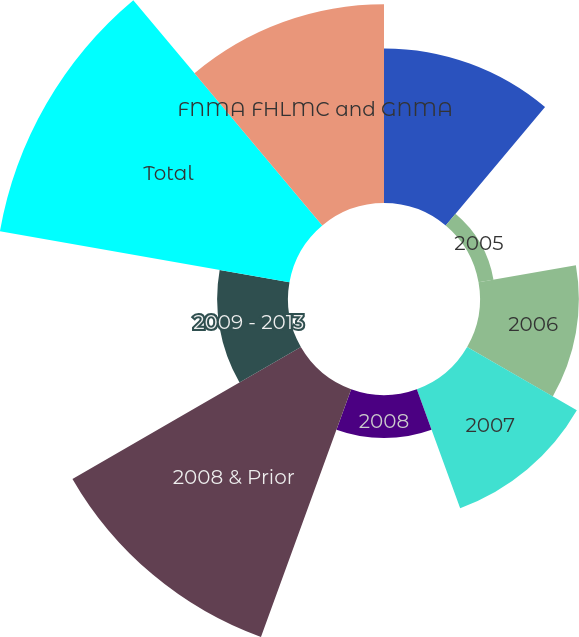Convert chart. <chart><loc_0><loc_0><loc_500><loc_500><pie_chart><fcel>2004 & Prior<fcel>2005<fcel>2006<fcel>2007<fcel>2008<fcel>2008 & Prior<fcel>2009 - 2013<fcel>Total<fcel>FNMA FHLMC and GNMA<nl><fcel>12.21%<fcel>1.2%<fcel>7.81%<fcel>10.01%<fcel>3.4%<fcel>20.84%<fcel>5.6%<fcel>23.23%<fcel>15.71%<nl></chart> 